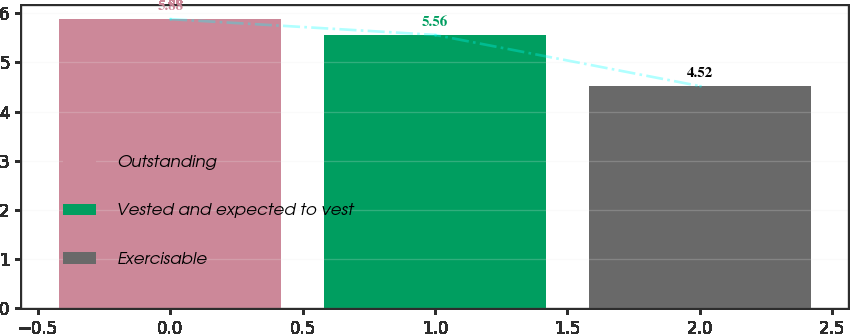Convert chart. <chart><loc_0><loc_0><loc_500><loc_500><bar_chart><fcel>Outstanding<fcel>Vested and expected to vest<fcel>Exercisable<nl><fcel>5.88<fcel>5.56<fcel>4.52<nl></chart> 